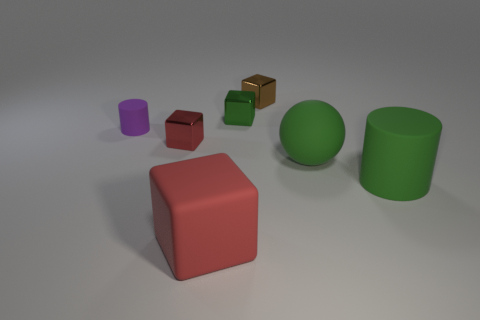Subtract all gray blocks. Subtract all green cylinders. How many blocks are left? 4 Add 1 green rubber objects. How many objects exist? 8 Subtract all cylinders. How many objects are left? 5 Subtract all tiny green metal objects. Subtract all rubber cubes. How many objects are left? 5 Add 1 small metal cubes. How many small metal cubes are left? 4 Add 3 big brown rubber cubes. How many big brown rubber cubes exist? 3 Subtract 1 brown blocks. How many objects are left? 6 